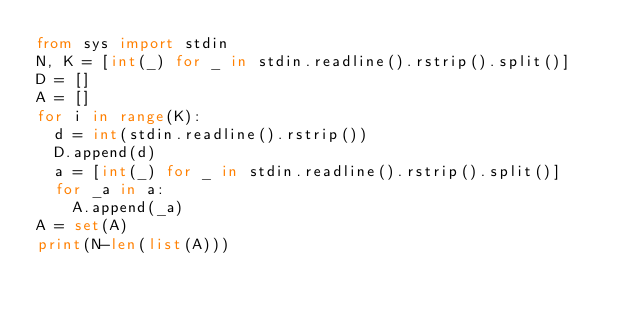Convert code to text. <code><loc_0><loc_0><loc_500><loc_500><_Python_>from sys import stdin
N, K = [int(_) for _ in stdin.readline().rstrip().split()]
D = []
A = []
for i in range(K):
  d = int(stdin.readline().rstrip())
  D.append(d)
  a = [int(_) for _ in stdin.readline().rstrip().split()]
  for _a in a:
    A.append(_a)
A = set(A)
print(N-len(list(A)))</code> 